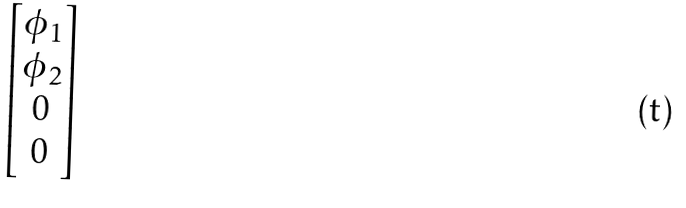<formula> <loc_0><loc_0><loc_500><loc_500>\begin{bmatrix} \phi _ { 1 } \\ \phi _ { 2 } \\ 0 \\ 0 \end{bmatrix}</formula> 